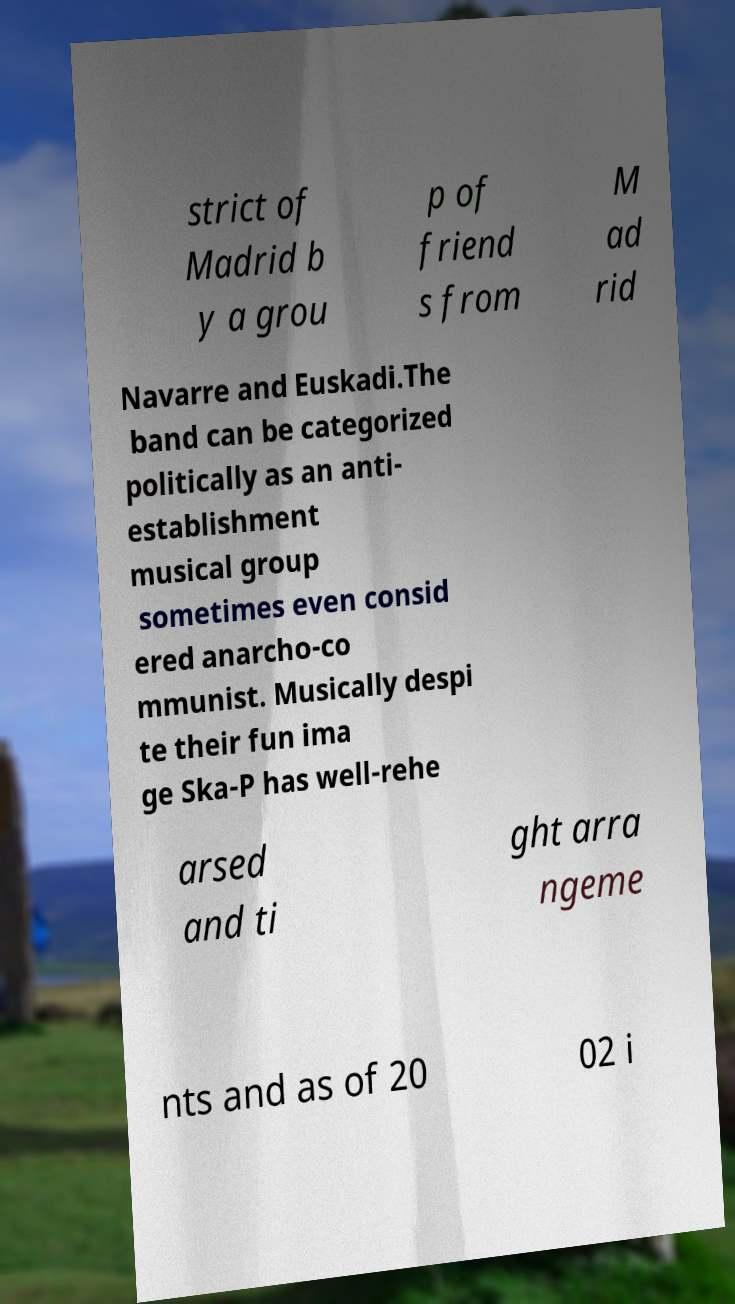Please identify and transcribe the text found in this image. strict of Madrid b y a grou p of friend s from M ad rid Navarre and Euskadi.The band can be categorized politically as an anti- establishment musical group sometimes even consid ered anarcho-co mmunist. Musically despi te their fun ima ge Ska-P has well-rehe arsed and ti ght arra ngeme nts and as of 20 02 i 